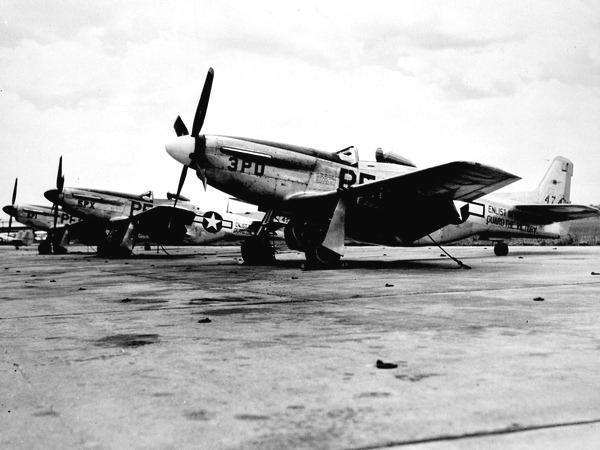How many airplanes are there?
Give a very brief answer. 3. How many towers have clocks on them?
Give a very brief answer. 0. 